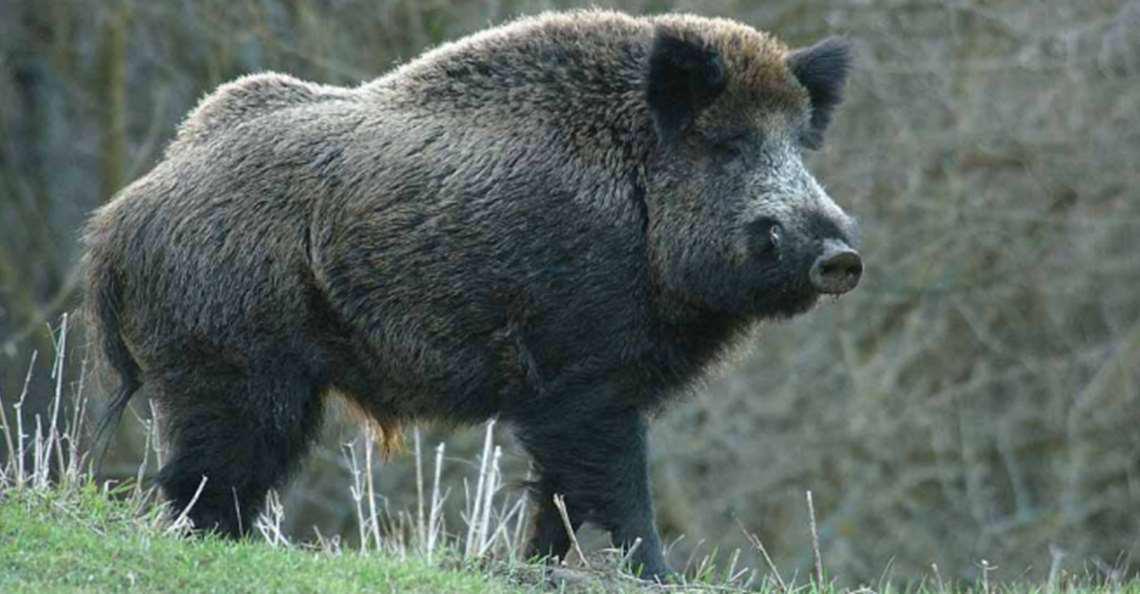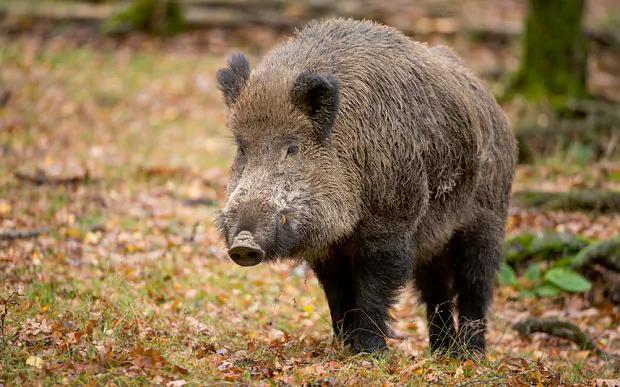The first image is the image on the left, the second image is the image on the right. Considering the images on both sides, is "The animal in the image on the left has its body turned to the right." valid? Answer yes or no. Yes. 